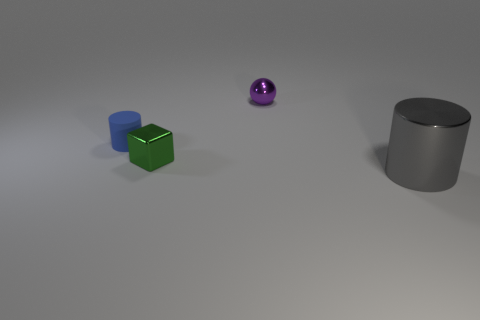Add 1 purple spheres. How many objects exist? 5 Subtract 1 cylinders. How many cylinders are left? 1 Subtract all cubes. How many objects are left? 3 Subtract all metallic blocks. Subtract all blue cylinders. How many objects are left? 2 Add 4 large gray things. How many large gray things are left? 5 Add 3 cubes. How many cubes exist? 4 Subtract 0 red balls. How many objects are left? 4 